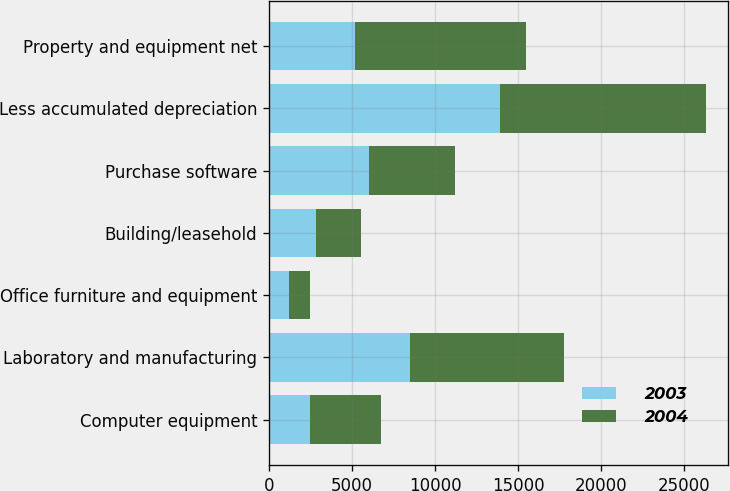Convert chart to OTSL. <chart><loc_0><loc_0><loc_500><loc_500><stacked_bar_chart><ecel><fcel>Computer equipment<fcel>Laboratory and manufacturing<fcel>Office furniture and equipment<fcel>Building/leasehold<fcel>Purchase software<fcel>Less accumulated depreciation<fcel>Property and equipment net<nl><fcel>2003<fcel>2463<fcel>8473<fcel>1171<fcel>2805<fcel>6015<fcel>13895<fcel>5187<nl><fcel>2004<fcel>4262<fcel>9270<fcel>1264<fcel>2714<fcel>5187<fcel>12409<fcel>10288<nl></chart> 